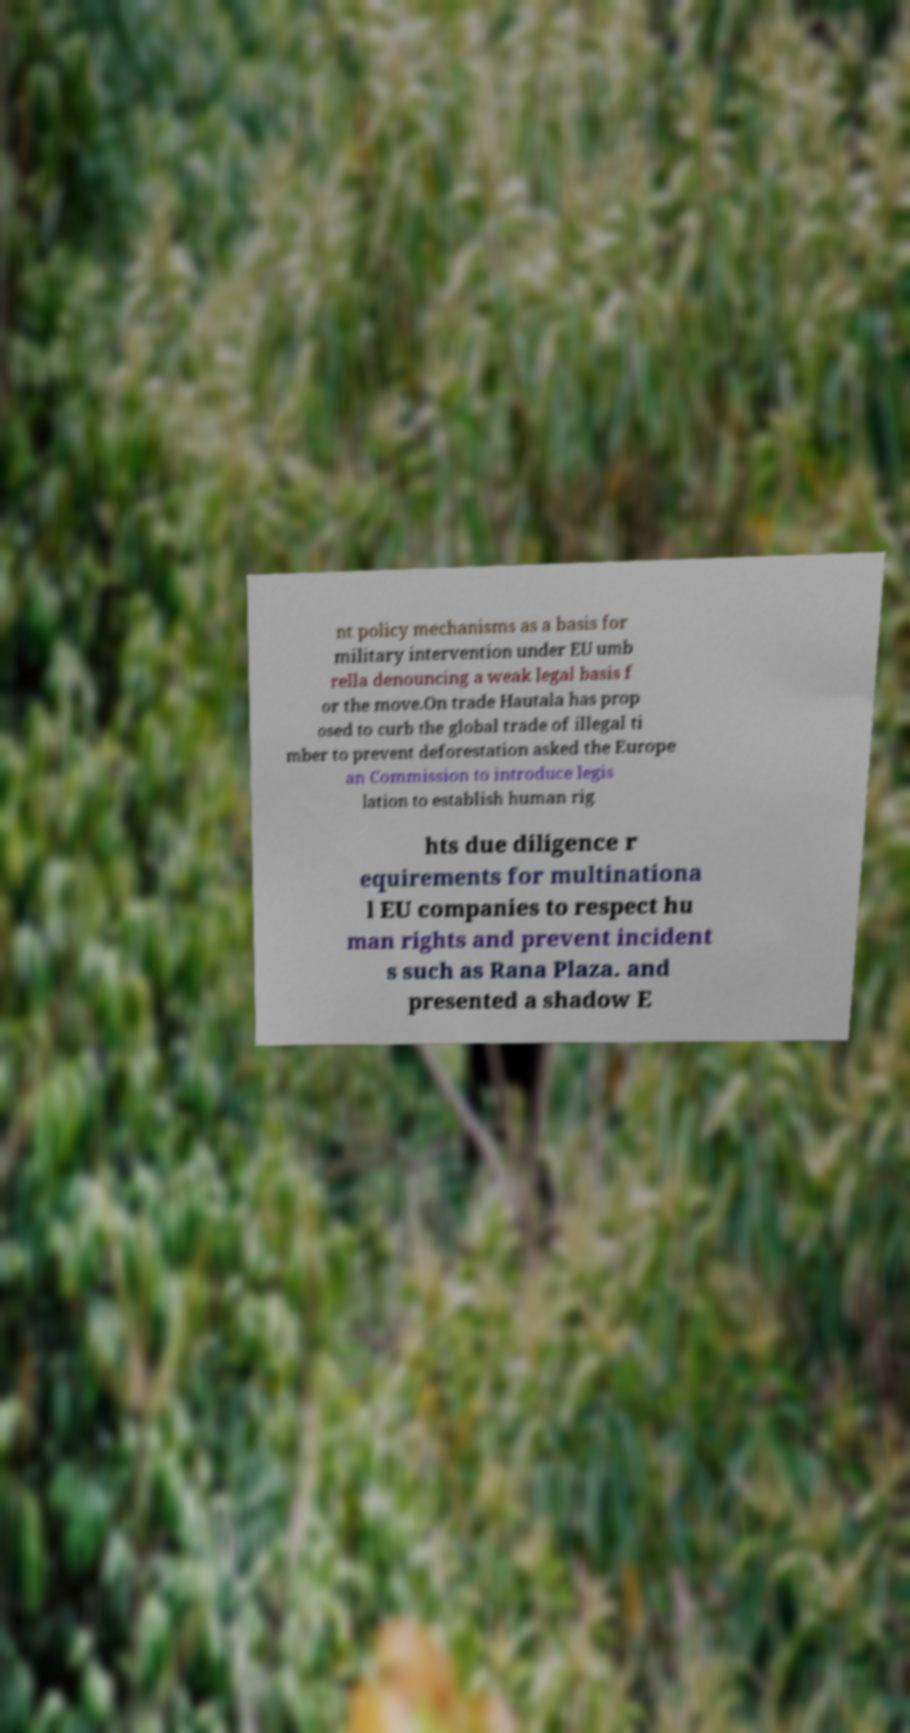There's text embedded in this image that I need extracted. Can you transcribe it verbatim? nt policy mechanisms as a basis for military intervention under EU umb rella denouncing a weak legal basis f or the move.On trade Hautala has prop osed to curb the global trade of illegal ti mber to prevent deforestation asked the Europe an Commission to introduce legis lation to establish human rig hts due diligence r equirements for multinationa l EU companies to respect hu man rights and prevent incident s such as Rana Plaza. and presented a shadow E 